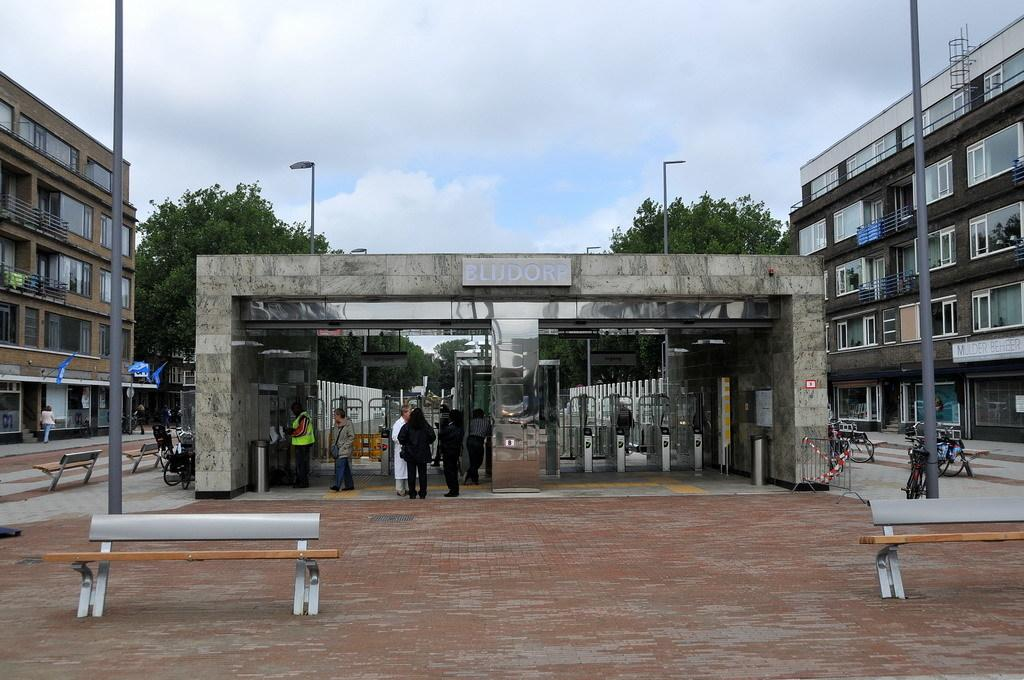What type of structures can be seen in the image? There are buildings in the image. Who or what else is present in the image? There are people and automated ticket checking machines in the image. What is available for disposing of waste in the image? There is a dustbin in the image. What can be used for sitting or resting in the image? There are benches on the road in the image. What mode of transportation is visible in the image? There are bicycles in the image. What provides illumination at night in the image? There are street lights in the image. What can be seen in the sky in the image? There are clouds in the sky in the image. How many knees are visible in the image? There is no specific mention of knees in the image, so it is not possible to determine the number of knees visible. What type of place is depicted in the image? The image does not provide enough information to determine the specific type of place depicted. 